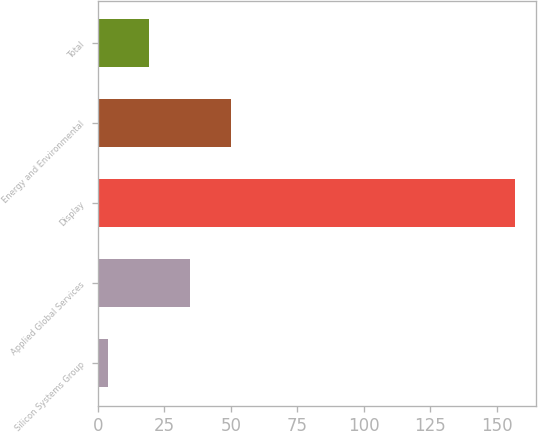Convert chart. <chart><loc_0><loc_0><loc_500><loc_500><bar_chart><fcel>Silicon Systems Group<fcel>Applied Global Services<fcel>Display<fcel>Energy and Environmental<fcel>Total<nl><fcel>4<fcel>34.6<fcel>157<fcel>49.9<fcel>19.3<nl></chart> 